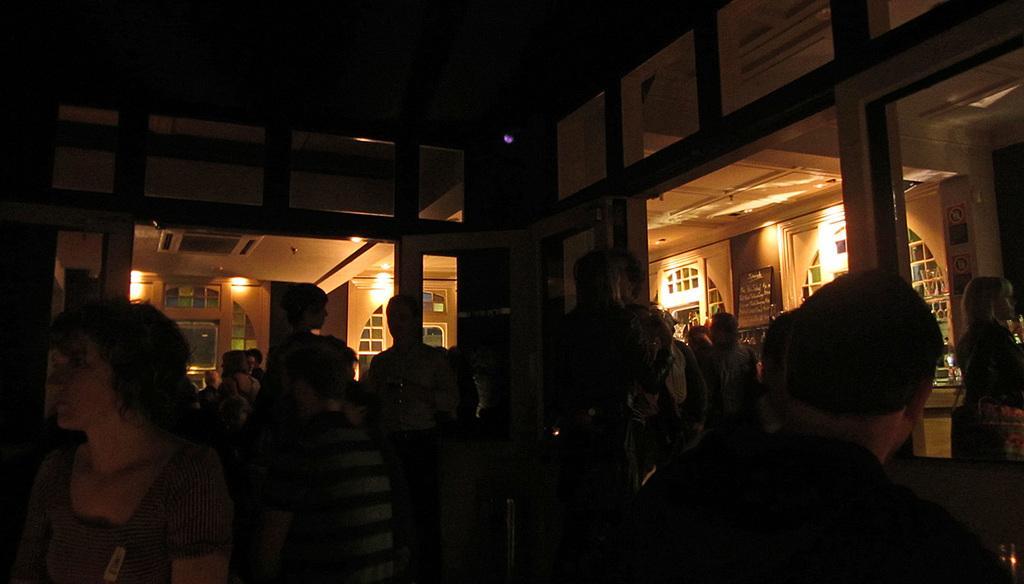How would you summarize this image in a sentence or two? In this image, we can see an inside view of a building. There is a crowd at the bottom of the image. 